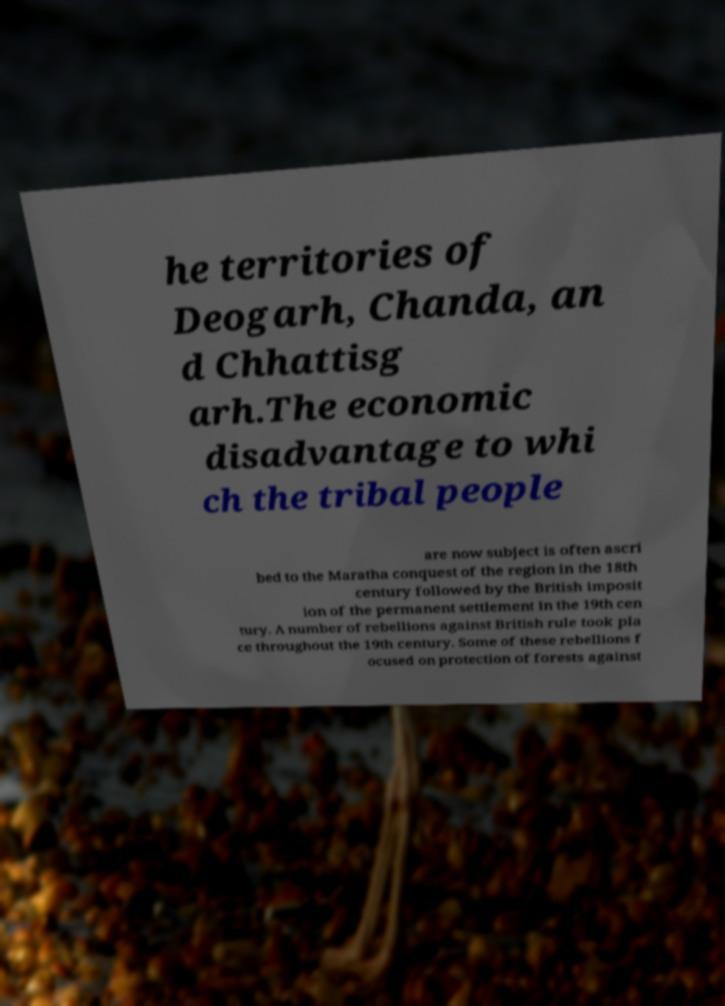Could you extract and type out the text from this image? he territories of Deogarh, Chanda, an d Chhattisg arh.The economic disadvantage to whi ch the tribal people are now subject is often ascri bed to the Maratha conquest of the region in the 18th century followed by the British imposit ion of the permanent settlement in the 19th cen tury. A number of rebellions against British rule took pla ce throughout the 19th century. Some of these rebellions f ocused on protection of forests against 